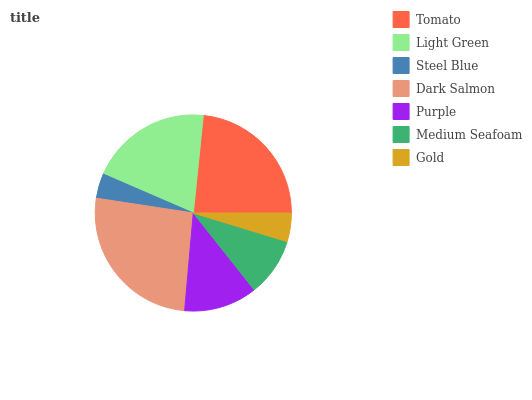Is Steel Blue the minimum?
Answer yes or no. Yes. Is Dark Salmon the maximum?
Answer yes or no. Yes. Is Light Green the minimum?
Answer yes or no. No. Is Light Green the maximum?
Answer yes or no. No. Is Tomato greater than Light Green?
Answer yes or no. Yes. Is Light Green less than Tomato?
Answer yes or no. Yes. Is Light Green greater than Tomato?
Answer yes or no. No. Is Tomato less than Light Green?
Answer yes or no. No. Is Purple the high median?
Answer yes or no. Yes. Is Purple the low median?
Answer yes or no. Yes. Is Steel Blue the high median?
Answer yes or no. No. Is Tomato the low median?
Answer yes or no. No. 